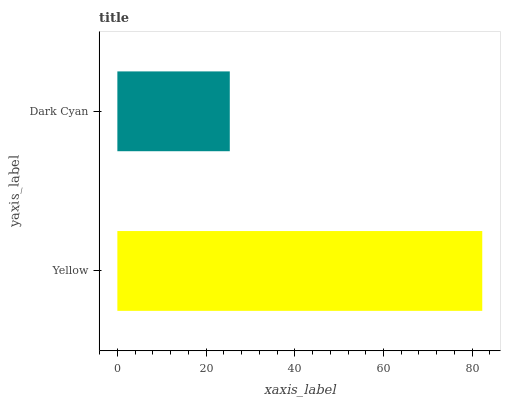Is Dark Cyan the minimum?
Answer yes or no. Yes. Is Yellow the maximum?
Answer yes or no. Yes. Is Dark Cyan the maximum?
Answer yes or no. No. Is Yellow greater than Dark Cyan?
Answer yes or no. Yes. Is Dark Cyan less than Yellow?
Answer yes or no. Yes. Is Dark Cyan greater than Yellow?
Answer yes or no. No. Is Yellow less than Dark Cyan?
Answer yes or no. No. Is Yellow the high median?
Answer yes or no. Yes. Is Dark Cyan the low median?
Answer yes or no. Yes. Is Dark Cyan the high median?
Answer yes or no. No. Is Yellow the low median?
Answer yes or no. No. 